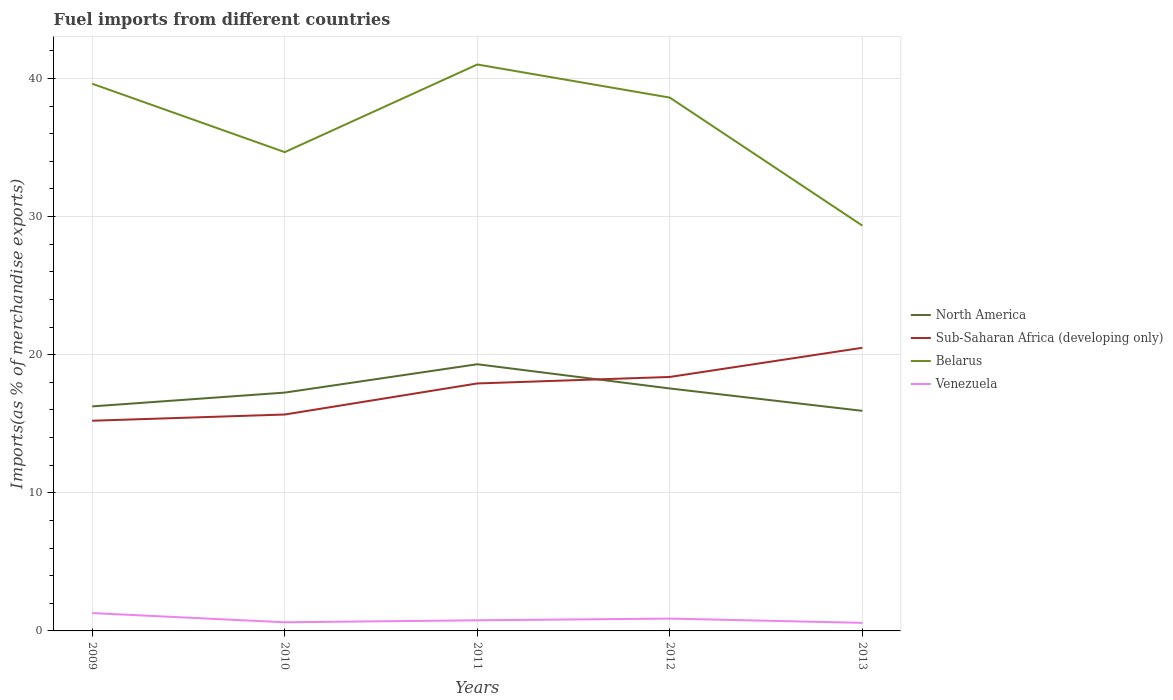How many different coloured lines are there?
Make the answer very short. 4. Does the line corresponding to North America intersect with the line corresponding to Belarus?
Give a very brief answer. No. Across all years, what is the maximum percentage of imports to different countries in Venezuela?
Provide a succinct answer. 0.58. In which year was the percentage of imports to different countries in Sub-Saharan Africa (developing only) maximum?
Your response must be concise. 2009. What is the total percentage of imports to different countries in Belarus in the graph?
Offer a terse response. 2.4. What is the difference between the highest and the second highest percentage of imports to different countries in Sub-Saharan Africa (developing only)?
Your response must be concise. 5.28. What is the difference between the highest and the lowest percentage of imports to different countries in Venezuela?
Your answer should be very brief. 2. How many years are there in the graph?
Your response must be concise. 5. Are the values on the major ticks of Y-axis written in scientific E-notation?
Your response must be concise. No. Does the graph contain grids?
Your answer should be very brief. Yes. How are the legend labels stacked?
Provide a succinct answer. Vertical. What is the title of the graph?
Keep it short and to the point. Fuel imports from different countries. What is the label or title of the Y-axis?
Make the answer very short. Imports(as % of merchandise exports). What is the Imports(as % of merchandise exports) of North America in 2009?
Your answer should be compact. 16.25. What is the Imports(as % of merchandise exports) of Sub-Saharan Africa (developing only) in 2009?
Your response must be concise. 15.22. What is the Imports(as % of merchandise exports) of Belarus in 2009?
Provide a succinct answer. 39.61. What is the Imports(as % of merchandise exports) in Venezuela in 2009?
Your answer should be compact. 1.29. What is the Imports(as % of merchandise exports) in North America in 2010?
Your response must be concise. 17.25. What is the Imports(as % of merchandise exports) in Sub-Saharan Africa (developing only) in 2010?
Your response must be concise. 15.67. What is the Imports(as % of merchandise exports) of Belarus in 2010?
Offer a terse response. 34.66. What is the Imports(as % of merchandise exports) of Venezuela in 2010?
Provide a short and direct response. 0.63. What is the Imports(as % of merchandise exports) of North America in 2011?
Offer a terse response. 19.31. What is the Imports(as % of merchandise exports) in Sub-Saharan Africa (developing only) in 2011?
Give a very brief answer. 17.91. What is the Imports(as % of merchandise exports) in Belarus in 2011?
Your response must be concise. 41. What is the Imports(as % of merchandise exports) in Venezuela in 2011?
Make the answer very short. 0.77. What is the Imports(as % of merchandise exports) in North America in 2012?
Your answer should be compact. 17.55. What is the Imports(as % of merchandise exports) of Sub-Saharan Africa (developing only) in 2012?
Provide a succinct answer. 18.39. What is the Imports(as % of merchandise exports) of Belarus in 2012?
Offer a terse response. 38.61. What is the Imports(as % of merchandise exports) in Venezuela in 2012?
Make the answer very short. 0.89. What is the Imports(as % of merchandise exports) in North America in 2013?
Offer a very short reply. 15.93. What is the Imports(as % of merchandise exports) in Sub-Saharan Africa (developing only) in 2013?
Offer a terse response. 20.5. What is the Imports(as % of merchandise exports) in Belarus in 2013?
Make the answer very short. 29.34. What is the Imports(as % of merchandise exports) of Venezuela in 2013?
Your response must be concise. 0.58. Across all years, what is the maximum Imports(as % of merchandise exports) in North America?
Your answer should be very brief. 19.31. Across all years, what is the maximum Imports(as % of merchandise exports) of Sub-Saharan Africa (developing only)?
Ensure brevity in your answer.  20.5. Across all years, what is the maximum Imports(as % of merchandise exports) of Belarus?
Provide a succinct answer. 41. Across all years, what is the maximum Imports(as % of merchandise exports) of Venezuela?
Offer a terse response. 1.29. Across all years, what is the minimum Imports(as % of merchandise exports) in North America?
Provide a short and direct response. 15.93. Across all years, what is the minimum Imports(as % of merchandise exports) in Sub-Saharan Africa (developing only)?
Give a very brief answer. 15.22. Across all years, what is the minimum Imports(as % of merchandise exports) of Belarus?
Offer a terse response. 29.34. Across all years, what is the minimum Imports(as % of merchandise exports) in Venezuela?
Your response must be concise. 0.58. What is the total Imports(as % of merchandise exports) in North America in the graph?
Your response must be concise. 86.3. What is the total Imports(as % of merchandise exports) in Sub-Saharan Africa (developing only) in the graph?
Keep it short and to the point. 87.68. What is the total Imports(as % of merchandise exports) in Belarus in the graph?
Your answer should be very brief. 183.23. What is the total Imports(as % of merchandise exports) of Venezuela in the graph?
Ensure brevity in your answer.  4.16. What is the difference between the Imports(as % of merchandise exports) of North America in 2009 and that in 2010?
Provide a succinct answer. -1. What is the difference between the Imports(as % of merchandise exports) of Sub-Saharan Africa (developing only) in 2009 and that in 2010?
Keep it short and to the point. -0.45. What is the difference between the Imports(as % of merchandise exports) in Belarus in 2009 and that in 2010?
Make the answer very short. 4.95. What is the difference between the Imports(as % of merchandise exports) in Venezuela in 2009 and that in 2010?
Give a very brief answer. 0.67. What is the difference between the Imports(as % of merchandise exports) in North America in 2009 and that in 2011?
Keep it short and to the point. -3.05. What is the difference between the Imports(as % of merchandise exports) in Sub-Saharan Africa (developing only) in 2009 and that in 2011?
Make the answer very short. -2.7. What is the difference between the Imports(as % of merchandise exports) of Belarus in 2009 and that in 2011?
Offer a very short reply. -1.39. What is the difference between the Imports(as % of merchandise exports) in Venezuela in 2009 and that in 2011?
Give a very brief answer. 0.52. What is the difference between the Imports(as % of merchandise exports) of North America in 2009 and that in 2012?
Offer a very short reply. -1.3. What is the difference between the Imports(as % of merchandise exports) of Sub-Saharan Africa (developing only) in 2009 and that in 2012?
Provide a succinct answer. -3.17. What is the difference between the Imports(as % of merchandise exports) in Belarus in 2009 and that in 2012?
Make the answer very short. 1. What is the difference between the Imports(as % of merchandise exports) of Venezuela in 2009 and that in 2012?
Give a very brief answer. 0.4. What is the difference between the Imports(as % of merchandise exports) of North America in 2009 and that in 2013?
Ensure brevity in your answer.  0.32. What is the difference between the Imports(as % of merchandise exports) of Sub-Saharan Africa (developing only) in 2009 and that in 2013?
Make the answer very short. -5.28. What is the difference between the Imports(as % of merchandise exports) in Belarus in 2009 and that in 2013?
Your answer should be very brief. 10.27. What is the difference between the Imports(as % of merchandise exports) in Venezuela in 2009 and that in 2013?
Your answer should be very brief. 0.71. What is the difference between the Imports(as % of merchandise exports) in North America in 2010 and that in 2011?
Give a very brief answer. -2.05. What is the difference between the Imports(as % of merchandise exports) of Sub-Saharan Africa (developing only) in 2010 and that in 2011?
Provide a short and direct response. -2.25. What is the difference between the Imports(as % of merchandise exports) in Belarus in 2010 and that in 2011?
Keep it short and to the point. -6.34. What is the difference between the Imports(as % of merchandise exports) in Venezuela in 2010 and that in 2011?
Keep it short and to the point. -0.14. What is the difference between the Imports(as % of merchandise exports) of North America in 2010 and that in 2012?
Give a very brief answer. -0.3. What is the difference between the Imports(as % of merchandise exports) of Sub-Saharan Africa (developing only) in 2010 and that in 2012?
Offer a very short reply. -2.72. What is the difference between the Imports(as % of merchandise exports) of Belarus in 2010 and that in 2012?
Give a very brief answer. -3.95. What is the difference between the Imports(as % of merchandise exports) in Venezuela in 2010 and that in 2012?
Ensure brevity in your answer.  -0.27. What is the difference between the Imports(as % of merchandise exports) of North America in 2010 and that in 2013?
Ensure brevity in your answer.  1.32. What is the difference between the Imports(as % of merchandise exports) in Sub-Saharan Africa (developing only) in 2010 and that in 2013?
Your response must be concise. -4.83. What is the difference between the Imports(as % of merchandise exports) in Belarus in 2010 and that in 2013?
Make the answer very short. 5.32. What is the difference between the Imports(as % of merchandise exports) of Venezuela in 2010 and that in 2013?
Provide a succinct answer. 0.04. What is the difference between the Imports(as % of merchandise exports) of North America in 2011 and that in 2012?
Give a very brief answer. 1.75. What is the difference between the Imports(as % of merchandise exports) of Sub-Saharan Africa (developing only) in 2011 and that in 2012?
Your response must be concise. -0.47. What is the difference between the Imports(as % of merchandise exports) in Belarus in 2011 and that in 2012?
Ensure brevity in your answer.  2.4. What is the difference between the Imports(as % of merchandise exports) in Venezuela in 2011 and that in 2012?
Provide a succinct answer. -0.12. What is the difference between the Imports(as % of merchandise exports) of North America in 2011 and that in 2013?
Keep it short and to the point. 3.37. What is the difference between the Imports(as % of merchandise exports) in Sub-Saharan Africa (developing only) in 2011 and that in 2013?
Ensure brevity in your answer.  -2.58. What is the difference between the Imports(as % of merchandise exports) in Belarus in 2011 and that in 2013?
Offer a very short reply. 11.66. What is the difference between the Imports(as % of merchandise exports) of Venezuela in 2011 and that in 2013?
Provide a short and direct response. 0.19. What is the difference between the Imports(as % of merchandise exports) in North America in 2012 and that in 2013?
Keep it short and to the point. 1.62. What is the difference between the Imports(as % of merchandise exports) of Sub-Saharan Africa (developing only) in 2012 and that in 2013?
Your response must be concise. -2.11. What is the difference between the Imports(as % of merchandise exports) in Belarus in 2012 and that in 2013?
Give a very brief answer. 9.27. What is the difference between the Imports(as % of merchandise exports) in Venezuela in 2012 and that in 2013?
Ensure brevity in your answer.  0.31. What is the difference between the Imports(as % of merchandise exports) in North America in 2009 and the Imports(as % of merchandise exports) in Sub-Saharan Africa (developing only) in 2010?
Give a very brief answer. 0.59. What is the difference between the Imports(as % of merchandise exports) of North America in 2009 and the Imports(as % of merchandise exports) of Belarus in 2010?
Give a very brief answer. -18.41. What is the difference between the Imports(as % of merchandise exports) in North America in 2009 and the Imports(as % of merchandise exports) in Venezuela in 2010?
Your answer should be very brief. 15.63. What is the difference between the Imports(as % of merchandise exports) in Sub-Saharan Africa (developing only) in 2009 and the Imports(as % of merchandise exports) in Belarus in 2010?
Ensure brevity in your answer.  -19.44. What is the difference between the Imports(as % of merchandise exports) of Sub-Saharan Africa (developing only) in 2009 and the Imports(as % of merchandise exports) of Venezuela in 2010?
Your answer should be compact. 14.59. What is the difference between the Imports(as % of merchandise exports) in Belarus in 2009 and the Imports(as % of merchandise exports) in Venezuela in 2010?
Offer a terse response. 38.99. What is the difference between the Imports(as % of merchandise exports) in North America in 2009 and the Imports(as % of merchandise exports) in Sub-Saharan Africa (developing only) in 2011?
Your answer should be very brief. -1.66. What is the difference between the Imports(as % of merchandise exports) in North America in 2009 and the Imports(as % of merchandise exports) in Belarus in 2011?
Give a very brief answer. -24.75. What is the difference between the Imports(as % of merchandise exports) in North America in 2009 and the Imports(as % of merchandise exports) in Venezuela in 2011?
Ensure brevity in your answer.  15.49. What is the difference between the Imports(as % of merchandise exports) of Sub-Saharan Africa (developing only) in 2009 and the Imports(as % of merchandise exports) of Belarus in 2011?
Ensure brevity in your answer.  -25.79. What is the difference between the Imports(as % of merchandise exports) of Sub-Saharan Africa (developing only) in 2009 and the Imports(as % of merchandise exports) of Venezuela in 2011?
Your answer should be very brief. 14.45. What is the difference between the Imports(as % of merchandise exports) in Belarus in 2009 and the Imports(as % of merchandise exports) in Venezuela in 2011?
Provide a short and direct response. 38.84. What is the difference between the Imports(as % of merchandise exports) of North America in 2009 and the Imports(as % of merchandise exports) of Sub-Saharan Africa (developing only) in 2012?
Your response must be concise. -2.13. What is the difference between the Imports(as % of merchandise exports) of North America in 2009 and the Imports(as % of merchandise exports) of Belarus in 2012?
Make the answer very short. -22.35. What is the difference between the Imports(as % of merchandise exports) in North America in 2009 and the Imports(as % of merchandise exports) in Venezuela in 2012?
Offer a terse response. 15.36. What is the difference between the Imports(as % of merchandise exports) of Sub-Saharan Africa (developing only) in 2009 and the Imports(as % of merchandise exports) of Belarus in 2012?
Offer a very short reply. -23.39. What is the difference between the Imports(as % of merchandise exports) of Sub-Saharan Africa (developing only) in 2009 and the Imports(as % of merchandise exports) of Venezuela in 2012?
Ensure brevity in your answer.  14.32. What is the difference between the Imports(as % of merchandise exports) of Belarus in 2009 and the Imports(as % of merchandise exports) of Venezuela in 2012?
Offer a very short reply. 38.72. What is the difference between the Imports(as % of merchandise exports) of North America in 2009 and the Imports(as % of merchandise exports) of Sub-Saharan Africa (developing only) in 2013?
Make the answer very short. -4.24. What is the difference between the Imports(as % of merchandise exports) in North America in 2009 and the Imports(as % of merchandise exports) in Belarus in 2013?
Give a very brief answer. -13.09. What is the difference between the Imports(as % of merchandise exports) of North America in 2009 and the Imports(as % of merchandise exports) of Venezuela in 2013?
Your response must be concise. 15.67. What is the difference between the Imports(as % of merchandise exports) in Sub-Saharan Africa (developing only) in 2009 and the Imports(as % of merchandise exports) in Belarus in 2013?
Keep it short and to the point. -14.13. What is the difference between the Imports(as % of merchandise exports) of Sub-Saharan Africa (developing only) in 2009 and the Imports(as % of merchandise exports) of Venezuela in 2013?
Your answer should be very brief. 14.63. What is the difference between the Imports(as % of merchandise exports) in Belarus in 2009 and the Imports(as % of merchandise exports) in Venezuela in 2013?
Offer a terse response. 39.03. What is the difference between the Imports(as % of merchandise exports) in North America in 2010 and the Imports(as % of merchandise exports) in Sub-Saharan Africa (developing only) in 2011?
Make the answer very short. -0.66. What is the difference between the Imports(as % of merchandise exports) in North America in 2010 and the Imports(as % of merchandise exports) in Belarus in 2011?
Offer a terse response. -23.75. What is the difference between the Imports(as % of merchandise exports) in North America in 2010 and the Imports(as % of merchandise exports) in Venezuela in 2011?
Provide a succinct answer. 16.48. What is the difference between the Imports(as % of merchandise exports) of Sub-Saharan Africa (developing only) in 2010 and the Imports(as % of merchandise exports) of Belarus in 2011?
Ensure brevity in your answer.  -25.34. What is the difference between the Imports(as % of merchandise exports) in Sub-Saharan Africa (developing only) in 2010 and the Imports(as % of merchandise exports) in Venezuela in 2011?
Offer a very short reply. 14.9. What is the difference between the Imports(as % of merchandise exports) in Belarus in 2010 and the Imports(as % of merchandise exports) in Venezuela in 2011?
Provide a succinct answer. 33.89. What is the difference between the Imports(as % of merchandise exports) in North America in 2010 and the Imports(as % of merchandise exports) in Sub-Saharan Africa (developing only) in 2012?
Make the answer very short. -1.13. What is the difference between the Imports(as % of merchandise exports) of North America in 2010 and the Imports(as % of merchandise exports) of Belarus in 2012?
Provide a short and direct response. -21.36. What is the difference between the Imports(as % of merchandise exports) in North America in 2010 and the Imports(as % of merchandise exports) in Venezuela in 2012?
Your response must be concise. 16.36. What is the difference between the Imports(as % of merchandise exports) of Sub-Saharan Africa (developing only) in 2010 and the Imports(as % of merchandise exports) of Belarus in 2012?
Offer a very short reply. -22.94. What is the difference between the Imports(as % of merchandise exports) of Sub-Saharan Africa (developing only) in 2010 and the Imports(as % of merchandise exports) of Venezuela in 2012?
Your response must be concise. 14.77. What is the difference between the Imports(as % of merchandise exports) in Belarus in 2010 and the Imports(as % of merchandise exports) in Venezuela in 2012?
Offer a very short reply. 33.77. What is the difference between the Imports(as % of merchandise exports) of North America in 2010 and the Imports(as % of merchandise exports) of Sub-Saharan Africa (developing only) in 2013?
Give a very brief answer. -3.24. What is the difference between the Imports(as % of merchandise exports) in North America in 2010 and the Imports(as % of merchandise exports) in Belarus in 2013?
Offer a very short reply. -12.09. What is the difference between the Imports(as % of merchandise exports) in North America in 2010 and the Imports(as % of merchandise exports) in Venezuela in 2013?
Offer a very short reply. 16.67. What is the difference between the Imports(as % of merchandise exports) of Sub-Saharan Africa (developing only) in 2010 and the Imports(as % of merchandise exports) of Belarus in 2013?
Provide a short and direct response. -13.68. What is the difference between the Imports(as % of merchandise exports) of Sub-Saharan Africa (developing only) in 2010 and the Imports(as % of merchandise exports) of Venezuela in 2013?
Make the answer very short. 15.08. What is the difference between the Imports(as % of merchandise exports) of Belarus in 2010 and the Imports(as % of merchandise exports) of Venezuela in 2013?
Ensure brevity in your answer.  34.08. What is the difference between the Imports(as % of merchandise exports) in North America in 2011 and the Imports(as % of merchandise exports) in Sub-Saharan Africa (developing only) in 2012?
Offer a very short reply. 0.92. What is the difference between the Imports(as % of merchandise exports) in North America in 2011 and the Imports(as % of merchandise exports) in Belarus in 2012?
Your response must be concise. -19.3. What is the difference between the Imports(as % of merchandise exports) in North America in 2011 and the Imports(as % of merchandise exports) in Venezuela in 2012?
Offer a terse response. 18.41. What is the difference between the Imports(as % of merchandise exports) of Sub-Saharan Africa (developing only) in 2011 and the Imports(as % of merchandise exports) of Belarus in 2012?
Make the answer very short. -20.69. What is the difference between the Imports(as % of merchandise exports) in Sub-Saharan Africa (developing only) in 2011 and the Imports(as % of merchandise exports) in Venezuela in 2012?
Offer a terse response. 17.02. What is the difference between the Imports(as % of merchandise exports) of Belarus in 2011 and the Imports(as % of merchandise exports) of Venezuela in 2012?
Give a very brief answer. 40.11. What is the difference between the Imports(as % of merchandise exports) in North America in 2011 and the Imports(as % of merchandise exports) in Sub-Saharan Africa (developing only) in 2013?
Your response must be concise. -1.19. What is the difference between the Imports(as % of merchandise exports) of North America in 2011 and the Imports(as % of merchandise exports) of Belarus in 2013?
Keep it short and to the point. -10.04. What is the difference between the Imports(as % of merchandise exports) of North America in 2011 and the Imports(as % of merchandise exports) of Venezuela in 2013?
Your response must be concise. 18.72. What is the difference between the Imports(as % of merchandise exports) of Sub-Saharan Africa (developing only) in 2011 and the Imports(as % of merchandise exports) of Belarus in 2013?
Provide a short and direct response. -11.43. What is the difference between the Imports(as % of merchandise exports) of Sub-Saharan Africa (developing only) in 2011 and the Imports(as % of merchandise exports) of Venezuela in 2013?
Offer a very short reply. 17.33. What is the difference between the Imports(as % of merchandise exports) in Belarus in 2011 and the Imports(as % of merchandise exports) in Venezuela in 2013?
Provide a succinct answer. 40.42. What is the difference between the Imports(as % of merchandise exports) in North America in 2012 and the Imports(as % of merchandise exports) in Sub-Saharan Africa (developing only) in 2013?
Your answer should be very brief. -2.94. What is the difference between the Imports(as % of merchandise exports) in North America in 2012 and the Imports(as % of merchandise exports) in Belarus in 2013?
Ensure brevity in your answer.  -11.79. What is the difference between the Imports(as % of merchandise exports) of North America in 2012 and the Imports(as % of merchandise exports) of Venezuela in 2013?
Provide a short and direct response. 16.97. What is the difference between the Imports(as % of merchandise exports) of Sub-Saharan Africa (developing only) in 2012 and the Imports(as % of merchandise exports) of Belarus in 2013?
Keep it short and to the point. -10.96. What is the difference between the Imports(as % of merchandise exports) of Sub-Saharan Africa (developing only) in 2012 and the Imports(as % of merchandise exports) of Venezuela in 2013?
Make the answer very short. 17.8. What is the difference between the Imports(as % of merchandise exports) of Belarus in 2012 and the Imports(as % of merchandise exports) of Venezuela in 2013?
Keep it short and to the point. 38.02. What is the average Imports(as % of merchandise exports) in North America per year?
Offer a very short reply. 17.26. What is the average Imports(as % of merchandise exports) in Sub-Saharan Africa (developing only) per year?
Ensure brevity in your answer.  17.54. What is the average Imports(as % of merchandise exports) of Belarus per year?
Your answer should be compact. 36.65. What is the average Imports(as % of merchandise exports) of Venezuela per year?
Give a very brief answer. 0.83. In the year 2009, what is the difference between the Imports(as % of merchandise exports) in North America and Imports(as % of merchandise exports) in Sub-Saharan Africa (developing only)?
Your answer should be compact. 1.04. In the year 2009, what is the difference between the Imports(as % of merchandise exports) of North America and Imports(as % of merchandise exports) of Belarus?
Keep it short and to the point. -23.36. In the year 2009, what is the difference between the Imports(as % of merchandise exports) in North America and Imports(as % of merchandise exports) in Venezuela?
Your answer should be compact. 14.96. In the year 2009, what is the difference between the Imports(as % of merchandise exports) of Sub-Saharan Africa (developing only) and Imports(as % of merchandise exports) of Belarus?
Give a very brief answer. -24.4. In the year 2009, what is the difference between the Imports(as % of merchandise exports) in Sub-Saharan Africa (developing only) and Imports(as % of merchandise exports) in Venezuela?
Keep it short and to the point. 13.92. In the year 2009, what is the difference between the Imports(as % of merchandise exports) of Belarus and Imports(as % of merchandise exports) of Venezuela?
Make the answer very short. 38.32. In the year 2010, what is the difference between the Imports(as % of merchandise exports) in North America and Imports(as % of merchandise exports) in Sub-Saharan Africa (developing only)?
Give a very brief answer. 1.59. In the year 2010, what is the difference between the Imports(as % of merchandise exports) in North America and Imports(as % of merchandise exports) in Belarus?
Your response must be concise. -17.41. In the year 2010, what is the difference between the Imports(as % of merchandise exports) of North America and Imports(as % of merchandise exports) of Venezuela?
Provide a succinct answer. 16.63. In the year 2010, what is the difference between the Imports(as % of merchandise exports) in Sub-Saharan Africa (developing only) and Imports(as % of merchandise exports) in Belarus?
Your response must be concise. -19. In the year 2010, what is the difference between the Imports(as % of merchandise exports) of Sub-Saharan Africa (developing only) and Imports(as % of merchandise exports) of Venezuela?
Make the answer very short. 15.04. In the year 2010, what is the difference between the Imports(as % of merchandise exports) in Belarus and Imports(as % of merchandise exports) in Venezuela?
Make the answer very short. 34.03. In the year 2011, what is the difference between the Imports(as % of merchandise exports) in North America and Imports(as % of merchandise exports) in Sub-Saharan Africa (developing only)?
Provide a short and direct response. 1.39. In the year 2011, what is the difference between the Imports(as % of merchandise exports) of North America and Imports(as % of merchandise exports) of Belarus?
Your answer should be compact. -21.7. In the year 2011, what is the difference between the Imports(as % of merchandise exports) in North America and Imports(as % of merchandise exports) in Venezuela?
Keep it short and to the point. 18.54. In the year 2011, what is the difference between the Imports(as % of merchandise exports) in Sub-Saharan Africa (developing only) and Imports(as % of merchandise exports) in Belarus?
Provide a short and direct response. -23.09. In the year 2011, what is the difference between the Imports(as % of merchandise exports) of Sub-Saharan Africa (developing only) and Imports(as % of merchandise exports) of Venezuela?
Provide a short and direct response. 17.15. In the year 2011, what is the difference between the Imports(as % of merchandise exports) in Belarus and Imports(as % of merchandise exports) in Venezuela?
Your answer should be very brief. 40.24. In the year 2012, what is the difference between the Imports(as % of merchandise exports) of North America and Imports(as % of merchandise exports) of Sub-Saharan Africa (developing only)?
Give a very brief answer. -0.83. In the year 2012, what is the difference between the Imports(as % of merchandise exports) in North America and Imports(as % of merchandise exports) in Belarus?
Make the answer very short. -21.06. In the year 2012, what is the difference between the Imports(as % of merchandise exports) of North America and Imports(as % of merchandise exports) of Venezuela?
Provide a succinct answer. 16.66. In the year 2012, what is the difference between the Imports(as % of merchandise exports) of Sub-Saharan Africa (developing only) and Imports(as % of merchandise exports) of Belarus?
Ensure brevity in your answer.  -20.22. In the year 2012, what is the difference between the Imports(as % of merchandise exports) of Sub-Saharan Africa (developing only) and Imports(as % of merchandise exports) of Venezuela?
Make the answer very short. 17.49. In the year 2012, what is the difference between the Imports(as % of merchandise exports) of Belarus and Imports(as % of merchandise exports) of Venezuela?
Keep it short and to the point. 37.72. In the year 2013, what is the difference between the Imports(as % of merchandise exports) in North America and Imports(as % of merchandise exports) in Sub-Saharan Africa (developing only)?
Give a very brief answer. -4.57. In the year 2013, what is the difference between the Imports(as % of merchandise exports) in North America and Imports(as % of merchandise exports) in Belarus?
Ensure brevity in your answer.  -13.41. In the year 2013, what is the difference between the Imports(as % of merchandise exports) of North America and Imports(as % of merchandise exports) of Venezuela?
Provide a succinct answer. 15.35. In the year 2013, what is the difference between the Imports(as % of merchandise exports) in Sub-Saharan Africa (developing only) and Imports(as % of merchandise exports) in Belarus?
Make the answer very short. -8.84. In the year 2013, what is the difference between the Imports(as % of merchandise exports) in Sub-Saharan Africa (developing only) and Imports(as % of merchandise exports) in Venezuela?
Offer a terse response. 19.91. In the year 2013, what is the difference between the Imports(as % of merchandise exports) in Belarus and Imports(as % of merchandise exports) in Venezuela?
Give a very brief answer. 28.76. What is the ratio of the Imports(as % of merchandise exports) in North America in 2009 to that in 2010?
Give a very brief answer. 0.94. What is the ratio of the Imports(as % of merchandise exports) of Sub-Saharan Africa (developing only) in 2009 to that in 2010?
Give a very brief answer. 0.97. What is the ratio of the Imports(as % of merchandise exports) in Belarus in 2009 to that in 2010?
Make the answer very short. 1.14. What is the ratio of the Imports(as % of merchandise exports) of Venezuela in 2009 to that in 2010?
Give a very brief answer. 2.06. What is the ratio of the Imports(as % of merchandise exports) in North America in 2009 to that in 2011?
Keep it short and to the point. 0.84. What is the ratio of the Imports(as % of merchandise exports) of Sub-Saharan Africa (developing only) in 2009 to that in 2011?
Provide a short and direct response. 0.85. What is the ratio of the Imports(as % of merchandise exports) in Belarus in 2009 to that in 2011?
Offer a terse response. 0.97. What is the ratio of the Imports(as % of merchandise exports) in Venezuela in 2009 to that in 2011?
Your answer should be very brief. 1.68. What is the ratio of the Imports(as % of merchandise exports) in North America in 2009 to that in 2012?
Your answer should be compact. 0.93. What is the ratio of the Imports(as % of merchandise exports) of Sub-Saharan Africa (developing only) in 2009 to that in 2012?
Keep it short and to the point. 0.83. What is the ratio of the Imports(as % of merchandise exports) of Belarus in 2009 to that in 2012?
Ensure brevity in your answer.  1.03. What is the ratio of the Imports(as % of merchandise exports) in Venezuela in 2009 to that in 2012?
Your answer should be compact. 1.45. What is the ratio of the Imports(as % of merchandise exports) of North America in 2009 to that in 2013?
Your answer should be very brief. 1.02. What is the ratio of the Imports(as % of merchandise exports) in Sub-Saharan Africa (developing only) in 2009 to that in 2013?
Provide a succinct answer. 0.74. What is the ratio of the Imports(as % of merchandise exports) of Belarus in 2009 to that in 2013?
Keep it short and to the point. 1.35. What is the ratio of the Imports(as % of merchandise exports) of Venezuela in 2009 to that in 2013?
Offer a very short reply. 2.21. What is the ratio of the Imports(as % of merchandise exports) in North America in 2010 to that in 2011?
Give a very brief answer. 0.89. What is the ratio of the Imports(as % of merchandise exports) of Sub-Saharan Africa (developing only) in 2010 to that in 2011?
Provide a short and direct response. 0.87. What is the ratio of the Imports(as % of merchandise exports) in Belarus in 2010 to that in 2011?
Provide a short and direct response. 0.85. What is the ratio of the Imports(as % of merchandise exports) of Venezuela in 2010 to that in 2011?
Your answer should be compact. 0.81. What is the ratio of the Imports(as % of merchandise exports) of North America in 2010 to that in 2012?
Offer a very short reply. 0.98. What is the ratio of the Imports(as % of merchandise exports) in Sub-Saharan Africa (developing only) in 2010 to that in 2012?
Ensure brevity in your answer.  0.85. What is the ratio of the Imports(as % of merchandise exports) of Belarus in 2010 to that in 2012?
Your response must be concise. 0.9. What is the ratio of the Imports(as % of merchandise exports) in Venezuela in 2010 to that in 2012?
Offer a terse response. 0.7. What is the ratio of the Imports(as % of merchandise exports) in North America in 2010 to that in 2013?
Provide a succinct answer. 1.08. What is the ratio of the Imports(as % of merchandise exports) of Sub-Saharan Africa (developing only) in 2010 to that in 2013?
Your answer should be very brief. 0.76. What is the ratio of the Imports(as % of merchandise exports) in Belarus in 2010 to that in 2013?
Ensure brevity in your answer.  1.18. What is the ratio of the Imports(as % of merchandise exports) of Venezuela in 2010 to that in 2013?
Offer a terse response. 1.07. What is the ratio of the Imports(as % of merchandise exports) in North America in 2011 to that in 2012?
Offer a very short reply. 1.1. What is the ratio of the Imports(as % of merchandise exports) of Sub-Saharan Africa (developing only) in 2011 to that in 2012?
Your answer should be very brief. 0.97. What is the ratio of the Imports(as % of merchandise exports) in Belarus in 2011 to that in 2012?
Provide a short and direct response. 1.06. What is the ratio of the Imports(as % of merchandise exports) of Venezuela in 2011 to that in 2012?
Your answer should be compact. 0.86. What is the ratio of the Imports(as % of merchandise exports) of North America in 2011 to that in 2013?
Your answer should be compact. 1.21. What is the ratio of the Imports(as % of merchandise exports) in Sub-Saharan Africa (developing only) in 2011 to that in 2013?
Your answer should be compact. 0.87. What is the ratio of the Imports(as % of merchandise exports) in Belarus in 2011 to that in 2013?
Keep it short and to the point. 1.4. What is the ratio of the Imports(as % of merchandise exports) in Venezuela in 2011 to that in 2013?
Keep it short and to the point. 1.32. What is the ratio of the Imports(as % of merchandise exports) in North America in 2012 to that in 2013?
Provide a succinct answer. 1.1. What is the ratio of the Imports(as % of merchandise exports) in Sub-Saharan Africa (developing only) in 2012 to that in 2013?
Your answer should be very brief. 0.9. What is the ratio of the Imports(as % of merchandise exports) of Belarus in 2012 to that in 2013?
Offer a terse response. 1.32. What is the ratio of the Imports(as % of merchandise exports) of Venezuela in 2012 to that in 2013?
Your answer should be very brief. 1.53. What is the difference between the highest and the second highest Imports(as % of merchandise exports) in North America?
Give a very brief answer. 1.75. What is the difference between the highest and the second highest Imports(as % of merchandise exports) in Sub-Saharan Africa (developing only)?
Offer a terse response. 2.11. What is the difference between the highest and the second highest Imports(as % of merchandise exports) in Belarus?
Provide a succinct answer. 1.39. What is the difference between the highest and the second highest Imports(as % of merchandise exports) of Venezuela?
Your answer should be very brief. 0.4. What is the difference between the highest and the lowest Imports(as % of merchandise exports) in North America?
Make the answer very short. 3.37. What is the difference between the highest and the lowest Imports(as % of merchandise exports) in Sub-Saharan Africa (developing only)?
Your answer should be very brief. 5.28. What is the difference between the highest and the lowest Imports(as % of merchandise exports) in Belarus?
Give a very brief answer. 11.66. What is the difference between the highest and the lowest Imports(as % of merchandise exports) of Venezuela?
Give a very brief answer. 0.71. 